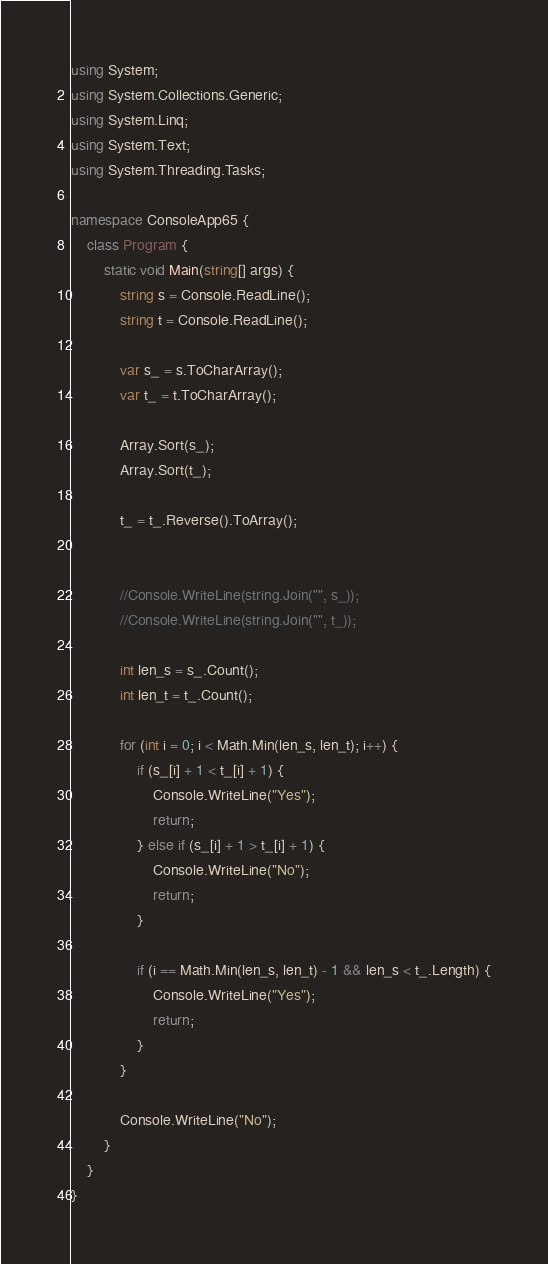<code> <loc_0><loc_0><loc_500><loc_500><_C#_>using System;
using System.Collections.Generic;
using System.Linq;
using System.Text;
using System.Threading.Tasks;

namespace ConsoleApp65 {
    class Program {
        static void Main(string[] args) {
            string s = Console.ReadLine();
            string t = Console.ReadLine();

            var s_ = s.ToCharArray();
            var t_ = t.ToCharArray();

            Array.Sort(s_);
            Array.Sort(t_);

            t_ = t_.Reverse().ToArray();


            //Console.WriteLine(string.Join("", s_));
            //Console.WriteLine(string.Join("", t_));

            int len_s = s_.Count();
            int len_t = t_.Count();

            for (int i = 0; i < Math.Min(len_s, len_t); i++) {
                if (s_[i] + 1 < t_[i] + 1) {
                    Console.WriteLine("Yes");
                    return;
                } else if (s_[i] + 1 > t_[i] + 1) {
                    Console.WriteLine("No");
                    return;
                }

                if (i == Math.Min(len_s, len_t) - 1 && len_s < t_.Length) {
                    Console.WriteLine("Yes");
                    return;
                }
            }

            Console.WriteLine("No");
        }
    }
}
</code> 